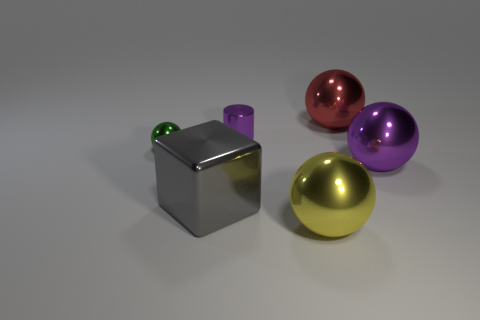How many other things are the same color as the metal cylinder?
Your response must be concise. 1. What is the color of the metallic ball that is in front of the large gray metal thing?
Your answer should be very brief. Yellow. Are there any yellow things that have the same size as the yellow shiny sphere?
Ensure brevity in your answer.  No. How many objects are either large spheres in front of the small purple metal cylinder or things that are in front of the large gray object?
Your answer should be compact. 2. Are there any tiny things that have the same shape as the large red object?
Offer a terse response. Yes. How many rubber things are either cylinders or yellow cubes?
Your answer should be very brief. 0. The tiny purple thing is what shape?
Ensure brevity in your answer.  Cylinder. What number of tiny spheres are made of the same material as the purple cylinder?
Keep it short and to the point. 1. What color is the cylinder that is the same material as the big purple ball?
Your answer should be very brief. Purple. Do the metallic ball behind the purple shiny cylinder and the big yellow ball have the same size?
Ensure brevity in your answer.  Yes. 